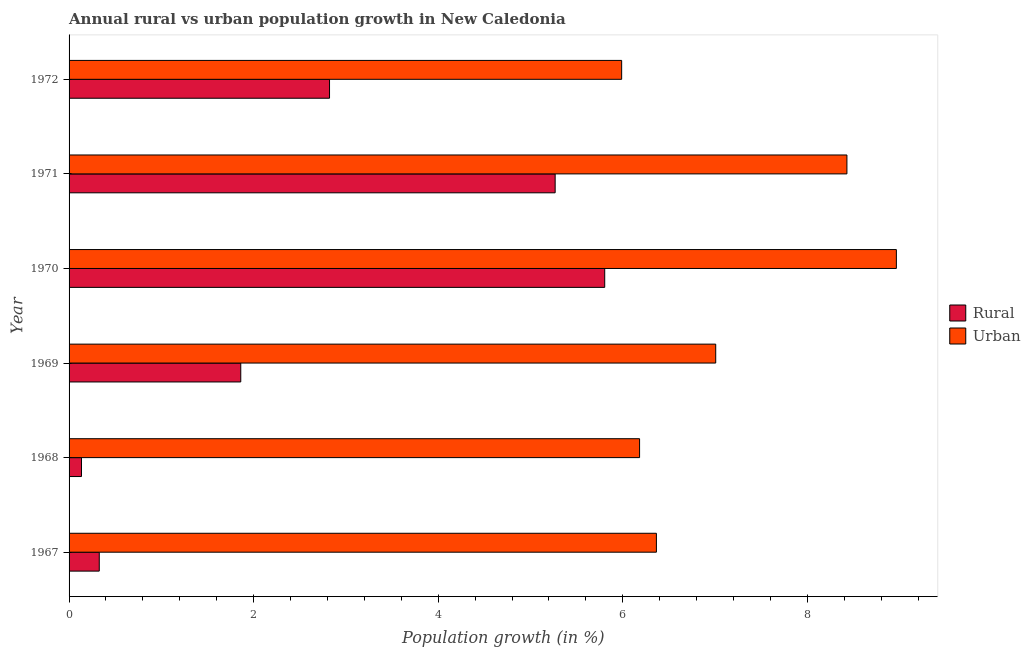How many groups of bars are there?
Make the answer very short. 6. Are the number of bars on each tick of the Y-axis equal?
Make the answer very short. Yes. How many bars are there on the 6th tick from the top?
Offer a very short reply. 2. How many bars are there on the 3rd tick from the bottom?
Your answer should be very brief. 2. What is the label of the 4th group of bars from the top?
Your answer should be compact. 1969. In how many cases, is the number of bars for a given year not equal to the number of legend labels?
Ensure brevity in your answer.  0. What is the rural population growth in 1970?
Make the answer very short. 5.8. Across all years, what is the maximum urban population growth?
Offer a very short reply. 8.96. Across all years, what is the minimum rural population growth?
Provide a short and direct response. 0.13. In which year was the urban population growth maximum?
Your response must be concise. 1970. In which year was the urban population growth minimum?
Provide a short and direct response. 1972. What is the total rural population growth in the graph?
Ensure brevity in your answer.  16.22. What is the difference between the urban population growth in 1968 and that in 1969?
Provide a succinct answer. -0.82. What is the difference between the rural population growth in 1967 and the urban population growth in 1970?
Your answer should be very brief. -8.64. What is the average rural population growth per year?
Make the answer very short. 2.7. In the year 1970, what is the difference between the rural population growth and urban population growth?
Your answer should be very brief. -3.16. In how many years, is the rural population growth greater than 4.4 %?
Your response must be concise. 2. What is the ratio of the urban population growth in 1968 to that in 1970?
Offer a terse response. 0.69. Is the difference between the rural population growth in 1971 and 1972 greater than the difference between the urban population growth in 1971 and 1972?
Ensure brevity in your answer.  Yes. What is the difference between the highest and the second highest rural population growth?
Make the answer very short. 0.54. What is the difference between the highest and the lowest urban population growth?
Give a very brief answer. 2.98. What does the 2nd bar from the top in 1972 represents?
Offer a very short reply. Rural. What does the 1st bar from the bottom in 1968 represents?
Make the answer very short. Rural. How many bars are there?
Give a very brief answer. 12. How many years are there in the graph?
Give a very brief answer. 6. What is the difference between two consecutive major ticks on the X-axis?
Provide a short and direct response. 2. Are the values on the major ticks of X-axis written in scientific E-notation?
Provide a succinct answer. No. Does the graph contain any zero values?
Make the answer very short. No. Does the graph contain grids?
Provide a succinct answer. No. Where does the legend appear in the graph?
Your answer should be compact. Center right. How many legend labels are there?
Offer a very short reply. 2. How are the legend labels stacked?
Offer a terse response. Vertical. What is the title of the graph?
Your answer should be compact. Annual rural vs urban population growth in New Caledonia. What is the label or title of the X-axis?
Provide a succinct answer. Population growth (in %). What is the Population growth (in %) of Rural in 1967?
Offer a terse response. 0.33. What is the Population growth (in %) of Urban  in 1967?
Provide a succinct answer. 6.36. What is the Population growth (in %) of Rural in 1968?
Ensure brevity in your answer.  0.13. What is the Population growth (in %) of Urban  in 1968?
Provide a succinct answer. 6.18. What is the Population growth (in %) of Rural in 1969?
Provide a short and direct response. 1.86. What is the Population growth (in %) of Urban  in 1969?
Offer a very short reply. 7.01. What is the Population growth (in %) of Rural in 1970?
Provide a short and direct response. 5.8. What is the Population growth (in %) of Urban  in 1970?
Ensure brevity in your answer.  8.96. What is the Population growth (in %) in Rural in 1971?
Keep it short and to the point. 5.27. What is the Population growth (in %) of Urban  in 1971?
Make the answer very short. 8.43. What is the Population growth (in %) of Rural in 1972?
Keep it short and to the point. 2.82. What is the Population growth (in %) in Urban  in 1972?
Provide a short and direct response. 5.99. Across all years, what is the maximum Population growth (in %) of Rural?
Give a very brief answer. 5.8. Across all years, what is the maximum Population growth (in %) in Urban ?
Your answer should be very brief. 8.96. Across all years, what is the minimum Population growth (in %) of Rural?
Offer a terse response. 0.13. Across all years, what is the minimum Population growth (in %) of Urban ?
Your response must be concise. 5.99. What is the total Population growth (in %) in Rural in the graph?
Provide a short and direct response. 16.22. What is the total Population growth (in %) of Urban  in the graph?
Your answer should be compact. 42.93. What is the difference between the Population growth (in %) in Rural in 1967 and that in 1968?
Ensure brevity in your answer.  0.19. What is the difference between the Population growth (in %) of Urban  in 1967 and that in 1968?
Offer a very short reply. 0.18. What is the difference between the Population growth (in %) of Rural in 1967 and that in 1969?
Your answer should be very brief. -1.53. What is the difference between the Population growth (in %) of Urban  in 1967 and that in 1969?
Offer a very short reply. -0.64. What is the difference between the Population growth (in %) of Rural in 1967 and that in 1970?
Give a very brief answer. -5.48. What is the difference between the Population growth (in %) in Urban  in 1967 and that in 1970?
Your answer should be compact. -2.6. What is the difference between the Population growth (in %) in Rural in 1967 and that in 1971?
Your answer should be compact. -4.94. What is the difference between the Population growth (in %) of Urban  in 1967 and that in 1971?
Make the answer very short. -2.06. What is the difference between the Population growth (in %) of Rural in 1967 and that in 1972?
Provide a short and direct response. -2.5. What is the difference between the Population growth (in %) in Urban  in 1967 and that in 1972?
Give a very brief answer. 0.38. What is the difference between the Population growth (in %) in Rural in 1968 and that in 1969?
Your response must be concise. -1.73. What is the difference between the Population growth (in %) in Urban  in 1968 and that in 1969?
Give a very brief answer. -0.82. What is the difference between the Population growth (in %) of Rural in 1968 and that in 1970?
Ensure brevity in your answer.  -5.67. What is the difference between the Population growth (in %) in Urban  in 1968 and that in 1970?
Provide a short and direct response. -2.78. What is the difference between the Population growth (in %) of Rural in 1968 and that in 1971?
Provide a succinct answer. -5.13. What is the difference between the Population growth (in %) in Urban  in 1968 and that in 1971?
Make the answer very short. -2.25. What is the difference between the Population growth (in %) in Rural in 1968 and that in 1972?
Keep it short and to the point. -2.69. What is the difference between the Population growth (in %) of Urban  in 1968 and that in 1972?
Keep it short and to the point. 0.19. What is the difference between the Population growth (in %) of Rural in 1969 and that in 1970?
Provide a succinct answer. -3.94. What is the difference between the Population growth (in %) of Urban  in 1969 and that in 1970?
Ensure brevity in your answer.  -1.96. What is the difference between the Population growth (in %) in Rural in 1969 and that in 1971?
Keep it short and to the point. -3.41. What is the difference between the Population growth (in %) of Urban  in 1969 and that in 1971?
Offer a terse response. -1.42. What is the difference between the Population growth (in %) in Rural in 1969 and that in 1972?
Provide a succinct answer. -0.96. What is the difference between the Population growth (in %) of Urban  in 1969 and that in 1972?
Your answer should be compact. 1.02. What is the difference between the Population growth (in %) in Rural in 1970 and that in 1971?
Keep it short and to the point. 0.54. What is the difference between the Population growth (in %) of Urban  in 1970 and that in 1971?
Make the answer very short. 0.54. What is the difference between the Population growth (in %) in Rural in 1970 and that in 1972?
Provide a succinct answer. 2.98. What is the difference between the Population growth (in %) of Urban  in 1970 and that in 1972?
Your answer should be very brief. 2.98. What is the difference between the Population growth (in %) of Rural in 1971 and that in 1972?
Your answer should be compact. 2.44. What is the difference between the Population growth (in %) of Urban  in 1971 and that in 1972?
Keep it short and to the point. 2.44. What is the difference between the Population growth (in %) in Rural in 1967 and the Population growth (in %) in Urban  in 1968?
Keep it short and to the point. -5.85. What is the difference between the Population growth (in %) in Rural in 1967 and the Population growth (in %) in Urban  in 1969?
Keep it short and to the point. -6.68. What is the difference between the Population growth (in %) of Rural in 1967 and the Population growth (in %) of Urban  in 1970?
Keep it short and to the point. -8.64. What is the difference between the Population growth (in %) in Rural in 1967 and the Population growth (in %) in Urban  in 1971?
Make the answer very short. -8.1. What is the difference between the Population growth (in %) of Rural in 1967 and the Population growth (in %) of Urban  in 1972?
Keep it short and to the point. -5.66. What is the difference between the Population growth (in %) in Rural in 1968 and the Population growth (in %) in Urban  in 1969?
Your response must be concise. -6.87. What is the difference between the Population growth (in %) of Rural in 1968 and the Population growth (in %) of Urban  in 1970?
Make the answer very short. -8.83. What is the difference between the Population growth (in %) of Rural in 1968 and the Population growth (in %) of Urban  in 1971?
Your answer should be compact. -8.29. What is the difference between the Population growth (in %) in Rural in 1968 and the Population growth (in %) in Urban  in 1972?
Give a very brief answer. -5.85. What is the difference between the Population growth (in %) in Rural in 1969 and the Population growth (in %) in Urban  in 1970?
Your response must be concise. -7.1. What is the difference between the Population growth (in %) of Rural in 1969 and the Population growth (in %) of Urban  in 1971?
Make the answer very short. -6.57. What is the difference between the Population growth (in %) of Rural in 1969 and the Population growth (in %) of Urban  in 1972?
Ensure brevity in your answer.  -4.13. What is the difference between the Population growth (in %) of Rural in 1970 and the Population growth (in %) of Urban  in 1971?
Your response must be concise. -2.62. What is the difference between the Population growth (in %) in Rural in 1970 and the Population growth (in %) in Urban  in 1972?
Ensure brevity in your answer.  -0.18. What is the difference between the Population growth (in %) in Rural in 1971 and the Population growth (in %) in Urban  in 1972?
Give a very brief answer. -0.72. What is the average Population growth (in %) of Rural per year?
Ensure brevity in your answer.  2.7. What is the average Population growth (in %) of Urban  per year?
Your answer should be compact. 7.16. In the year 1967, what is the difference between the Population growth (in %) of Rural and Population growth (in %) of Urban ?
Your response must be concise. -6.04. In the year 1968, what is the difference between the Population growth (in %) of Rural and Population growth (in %) of Urban ?
Your answer should be compact. -6.05. In the year 1969, what is the difference between the Population growth (in %) in Rural and Population growth (in %) in Urban ?
Your answer should be very brief. -5.15. In the year 1970, what is the difference between the Population growth (in %) in Rural and Population growth (in %) in Urban ?
Keep it short and to the point. -3.16. In the year 1971, what is the difference between the Population growth (in %) of Rural and Population growth (in %) of Urban ?
Ensure brevity in your answer.  -3.16. In the year 1972, what is the difference between the Population growth (in %) of Rural and Population growth (in %) of Urban ?
Provide a succinct answer. -3.17. What is the ratio of the Population growth (in %) in Rural in 1967 to that in 1968?
Provide a succinct answer. 2.43. What is the ratio of the Population growth (in %) in Urban  in 1967 to that in 1968?
Make the answer very short. 1.03. What is the ratio of the Population growth (in %) in Rural in 1967 to that in 1969?
Provide a succinct answer. 0.18. What is the ratio of the Population growth (in %) in Urban  in 1967 to that in 1969?
Keep it short and to the point. 0.91. What is the ratio of the Population growth (in %) of Rural in 1967 to that in 1970?
Offer a very short reply. 0.06. What is the ratio of the Population growth (in %) of Urban  in 1967 to that in 1970?
Offer a very short reply. 0.71. What is the ratio of the Population growth (in %) of Rural in 1967 to that in 1971?
Your answer should be very brief. 0.06. What is the ratio of the Population growth (in %) in Urban  in 1967 to that in 1971?
Make the answer very short. 0.76. What is the ratio of the Population growth (in %) of Rural in 1967 to that in 1972?
Provide a short and direct response. 0.12. What is the ratio of the Population growth (in %) of Urban  in 1967 to that in 1972?
Keep it short and to the point. 1.06. What is the ratio of the Population growth (in %) of Rural in 1968 to that in 1969?
Your answer should be compact. 0.07. What is the ratio of the Population growth (in %) of Urban  in 1968 to that in 1969?
Offer a very short reply. 0.88. What is the ratio of the Population growth (in %) in Rural in 1968 to that in 1970?
Provide a succinct answer. 0.02. What is the ratio of the Population growth (in %) of Urban  in 1968 to that in 1970?
Keep it short and to the point. 0.69. What is the ratio of the Population growth (in %) in Rural in 1968 to that in 1971?
Ensure brevity in your answer.  0.03. What is the ratio of the Population growth (in %) in Urban  in 1968 to that in 1971?
Ensure brevity in your answer.  0.73. What is the ratio of the Population growth (in %) of Rural in 1968 to that in 1972?
Provide a succinct answer. 0.05. What is the ratio of the Population growth (in %) in Urban  in 1968 to that in 1972?
Your answer should be very brief. 1.03. What is the ratio of the Population growth (in %) in Rural in 1969 to that in 1970?
Give a very brief answer. 0.32. What is the ratio of the Population growth (in %) of Urban  in 1969 to that in 1970?
Your response must be concise. 0.78. What is the ratio of the Population growth (in %) in Rural in 1969 to that in 1971?
Ensure brevity in your answer.  0.35. What is the ratio of the Population growth (in %) in Urban  in 1969 to that in 1971?
Your answer should be compact. 0.83. What is the ratio of the Population growth (in %) in Rural in 1969 to that in 1972?
Offer a very short reply. 0.66. What is the ratio of the Population growth (in %) in Urban  in 1969 to that in 1972?
Make the answer very short. 1.17. What is the ratio of the Population growth (in %) in Rural in 1970 to that in 1971?
Your answer should be very brief. 1.1. What is the ratio of the Population growth (in %) of Urban  in 1970 to that in 1971?
Ensure brevity in your answer.  1.06. What is the ratio of the Population growth (in %) of Rural in 1970 to that in 1972?
Offer a terse response. 2.06. What is the ratio of the Population growth (in %) in Urban  in 1970 to that in 1972?
Your answer should be compact. 1.5. What is the ratio of the Population growth (in %) in Rural in 1971 to that in 1972?
Give a very brief answer. 1.87. What is the ratio of the Population growth (in %) of Urban  in 1971 to that in 1972?
Your answer should be very brief. 1.41. What is the difference between the highest and the second highest Population growth (in %) in Rural?
Your answer should be compact. 0.54. What is the difference between the highest and the second highest Population growth (in %) in Urban ?
Offer a terse response. 0.54. What is the difference between the highest and the lowest Population growth (in %) in Rural?
Offer a terse response. 5.67. What is the difference between the highest and the lowest Population growth (in %) of Urban ?
Ensure brevity in your answer.  2.98. 